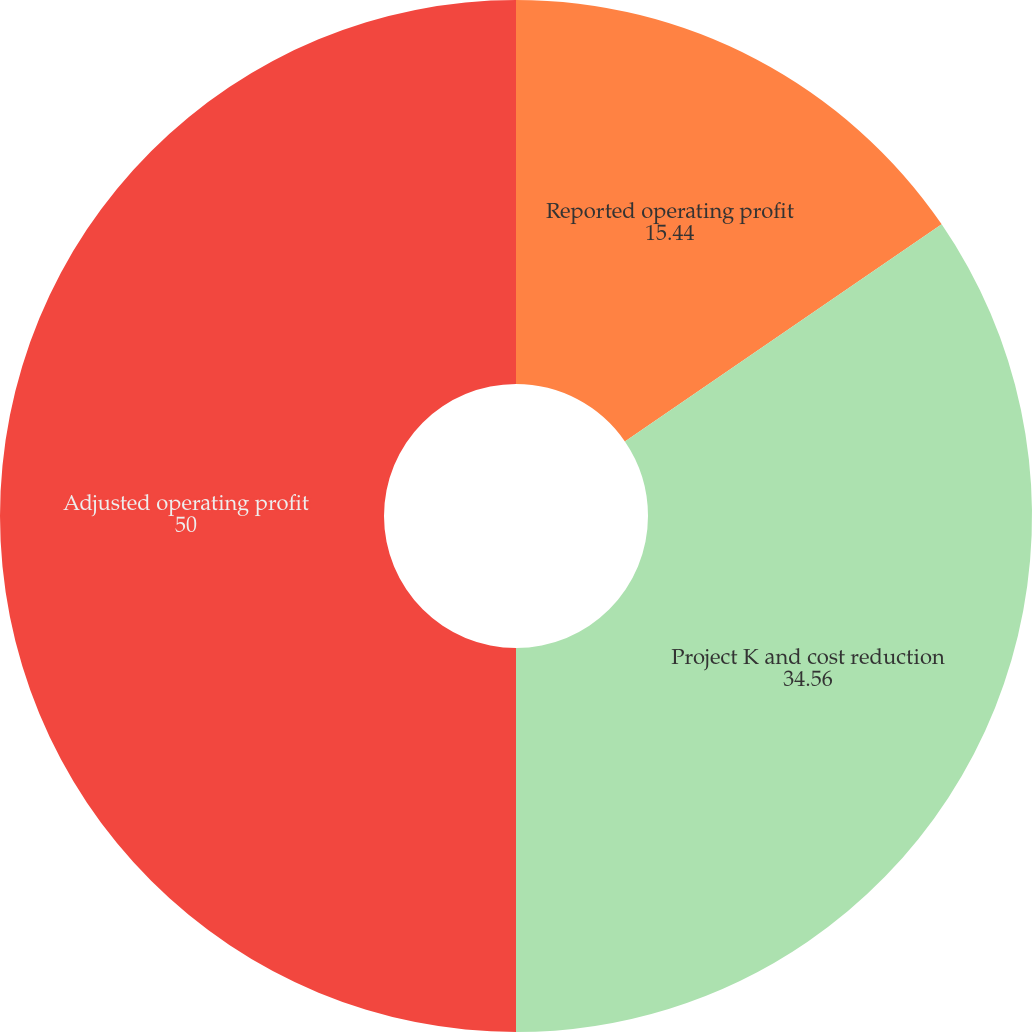<chart> <loc_0><loc_0><loc_500><loc_500><pie_chart><fcel>Reported operating profit<fcel>Project K and cost reduction<fcel>Adjusted operating profit<nl><fcel>15.44%<fcel>34.56%<fcel>50.0%<nl></chart> 